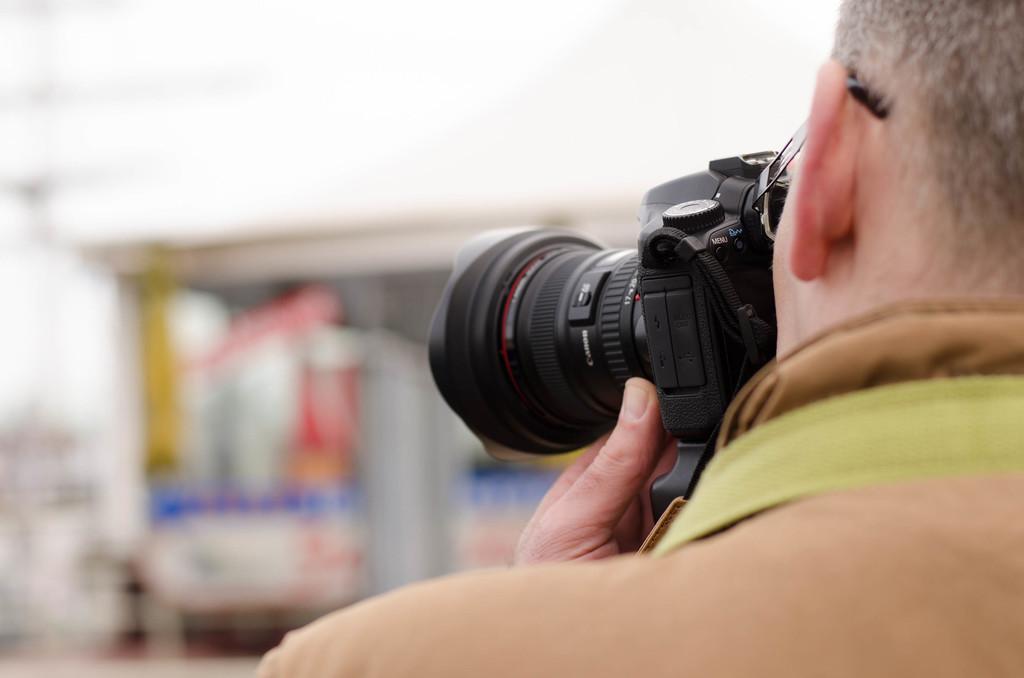In one or two sentences, can you explain what this image depicts? On the right hand side, there is a person in brown color shirt holding a camera and capturing a scenery which is in front of him. 